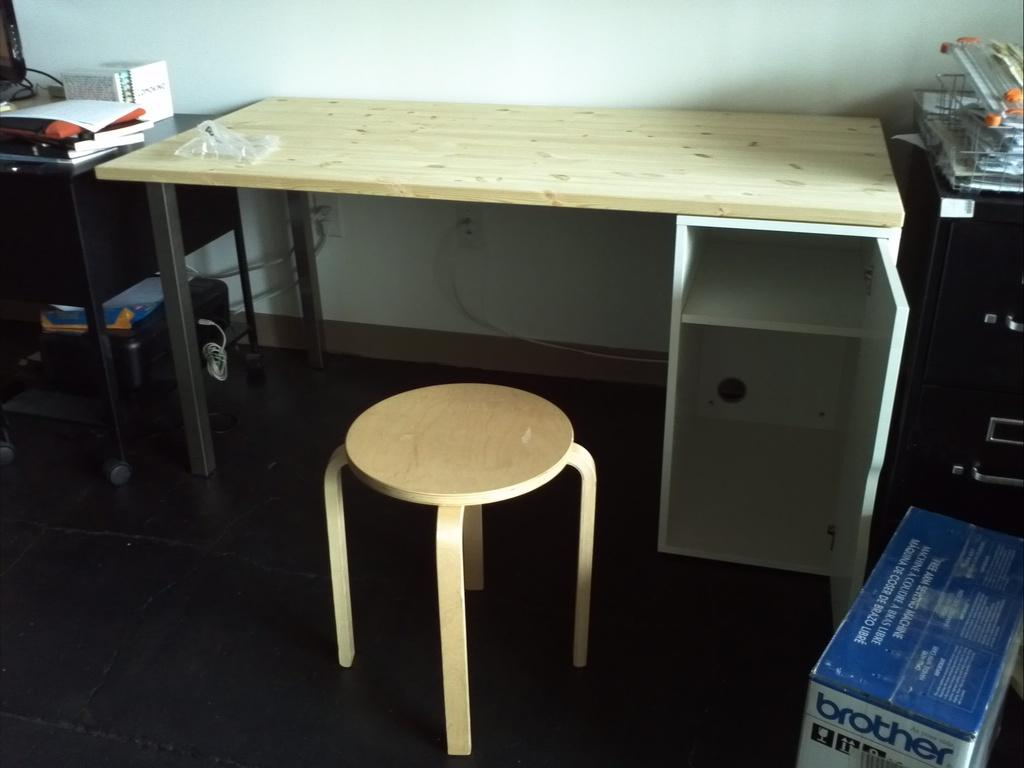<image>
Write a terse but informative summary of the picture. Room with a box on the ground that says Brother. 